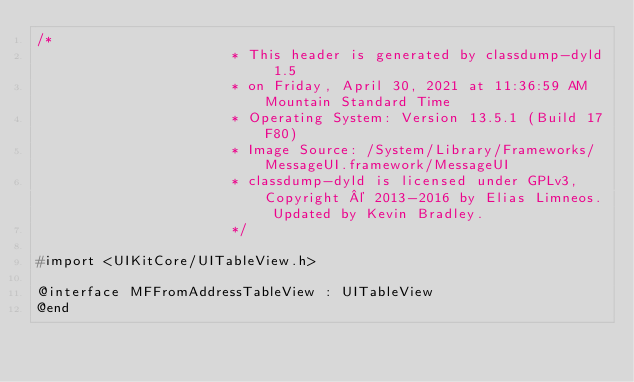Convert code to text. <code><loc_0><loc_0><loc_500><loc_500><_C_>/*
                       * This header is generated by classdump-dyld 1.5
                       * on Friday, April 30, 2021 at 11:36:59 AM Mountain Standard Time
                       * Operating System: Version 13.5.1 (Build 17F80)
                       * Image Source: /System/Library/Frameworks/MessageUI.framework/MessageUI
                       * classdump-dyld is licensed under GPLv3, Copyright © 2013-2016 by Elias Limneos. Updated by Kevin Bradley.
                       */

#import <UIKitCore/UITableView.h>

@interface MFFromAddressTableView : UITableView
@end

</code> 